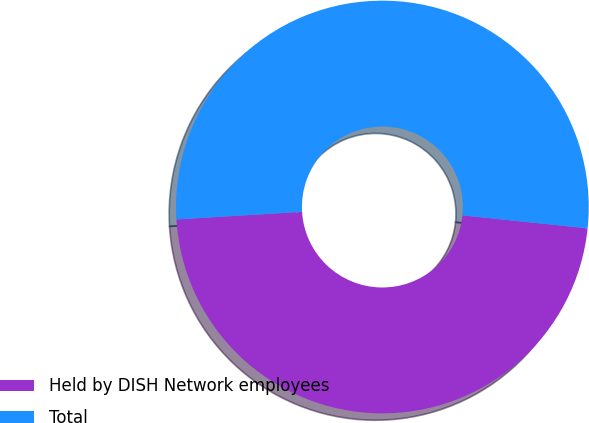Convert chart to OTSL. <chart><loc_0><loc_0><loc_500><loc_500><pie_chart><fcel>Held by DISH Network employees<fcel>Total<nl><fcel>47.39%<fcel>52.61%<nl></chart> 